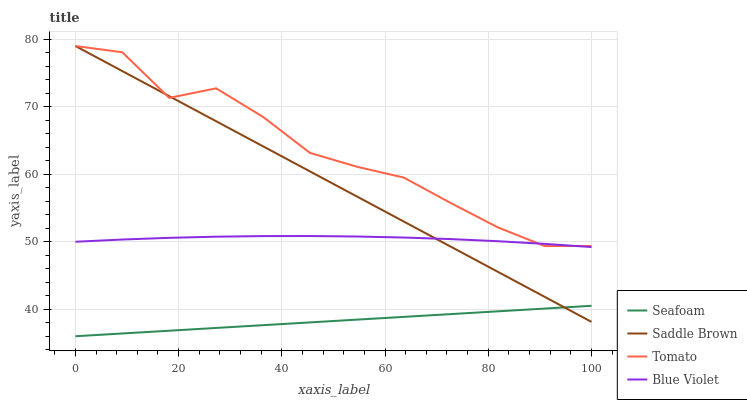Does Blue Violet have the minimum area under the curve?
Answer yes or no. No. Does Blue Violet have the maximum area under the curve?
Answer yes or no. No. Is Blue Violet the smoothest?
Answer yes or no. No. Is Blue Violet the roughest?
Answer yes or no. No. Does Blue Violet have the lowest value?
Answer yes or no. No. Does Blue Violet have the highest value?
Answer yes or no. No. Is Seafoam less than Tomato?
Answer yes or no. Yes. Is Blue Violet greater than Seafoam?
Answer yes or no. Yes. Does Seafoam intersect Tomato?
Answer yes or no. No. 